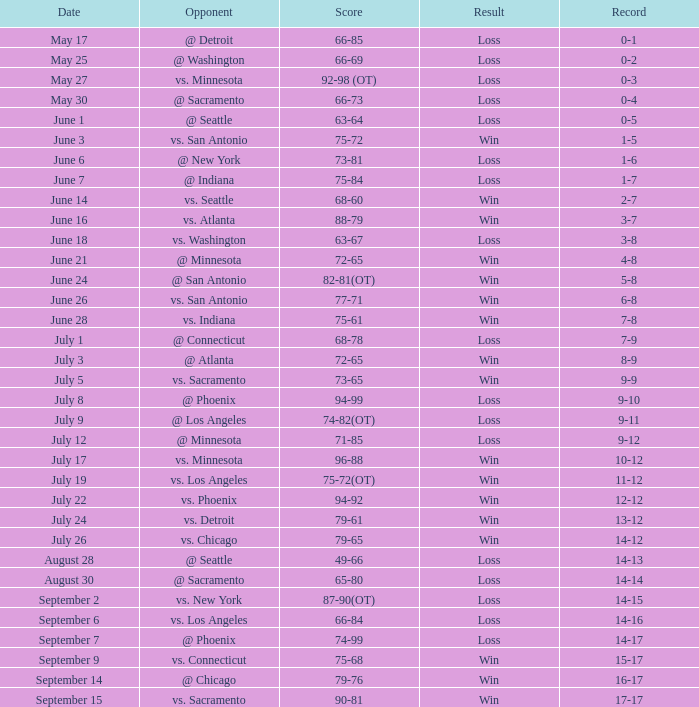What is the Date of the game with a Loss and Record of 7-9? July 1. 